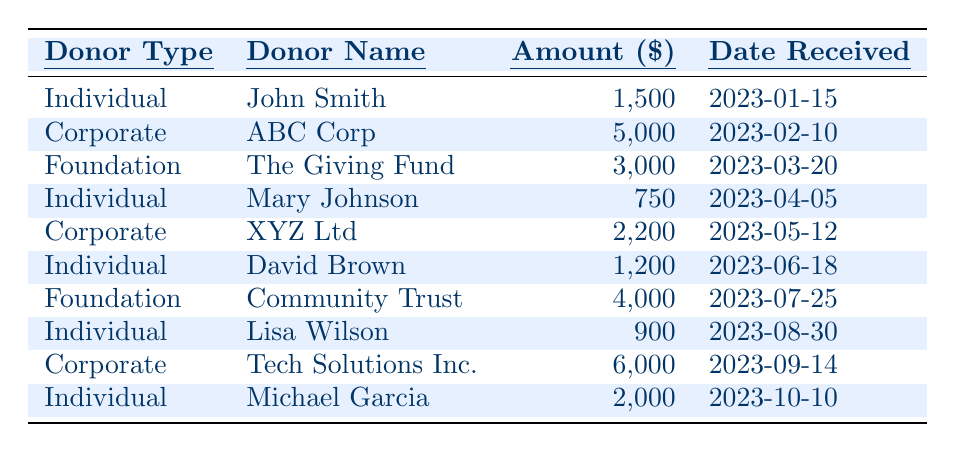What is the total amount received from Individual donors? The amounts received from Individual donors are listed as follows: 1,500 (John Smith), 750 (Mary Johnson), 1,200 (David Brown), 900 (Lisa Wilson), and 2,000 (Michael Garcia). Summing these amounts: 1,500 + 750 + 1,200 + 900 + 2,000 = 6,350.
Answer: 6,350 Which Corporate donor contributed the highest amount? Among the Corporate donors listed, ABC Corp contributed 5,000, XYZ Ltd contributed 2,200, and Tech Solutions Inc. contributed 6,000. Tech Solutions Inc. has the highest contribution at 6,000.
Answer: Tech Solutions Inc Did any Foundation donors contribute more than 3,500? The amounts received from Foundation donors are 3,000 (The Giving Fund) and 4,000 (Community Trust). Community Trust is the only one that contributed more than 3,500, as it contributed 4,000.
Answer: Yes What is the average donation amount received from Corporate donors? The Corporate donations are 5,000 (ABC Corp), 2,200 (XYZ Ltd), and 6,000 (Tech Solutions Inc.). To calculate the average, we first sum these amounts: 5,000 + 2,200 + 6,000 = 13,200. There are 3 Corporate donors, so the average is 13,200 / 3 = 4,400.
Answer: 4,400 How many donations were received in total? The table lists a total of 10 donations, with different donor types including Individual, Corporate, and Foundation. Simply counting the entries gives us 10.
Answer: 10 What is the total amount received from all donors in 2023? To find the total amount, we sum all the donations: 1,500 (John Smith) + 5,000 (ABC Corp) + 3,000 (The Giving Fund) + 750 (Mary Johnson) + 2,200 (XYZ Ltd) + 1,200 (David Brown) + 4,000 (Community Trust) + 900 (Lisa Wilson) + 6,000 (Tech Solutions Inc.) + 2,000 (Michael Garcia). The total is 1,500 + 5,000 + 3,000 + 750 + 2,200 + 1,200 + 4,000 + 900 + 6,000 + 2,000 = 26,550.
Answer: 26,550 Is there a donation received in August? Checking the table, we see that Lisa Wilson contributed on 2023-08-30, which is in August. Therefore, there is indeed a donation from August.
Answer: Yes How many Individual donations are greater than 1,000? The Individual donations over 1,000 are 1,500 (John Smith) and 2,000 (Michael Garcia). There are 2 such donations.
Answer: 2 What percentage of the total amount came from Corporate donors? Total from Corporate donations is 5,000 (ABC Corp) + 2,200 (XYZ Ltd) + 6,000 (Tech Solutions Inc.) = 13,200. The total amount of donations is 26,550. To find the percentage: (13,200 / 26,550) * 100 = 49.7%.
Answer: 49.7% If we only consider the donations received in the first half of the year, what is the total amount? The first half donations are 1,500 (John Smith), 5,000 (ABC Corp), 750 (Mary Johnson), 2,200 (XYZ Ltd), and 1,200 (David Brown). Summing these: 1,500 + 5,000 + 750 + 2,200 + 1,200 = 10,650.
Answer: 10,650 